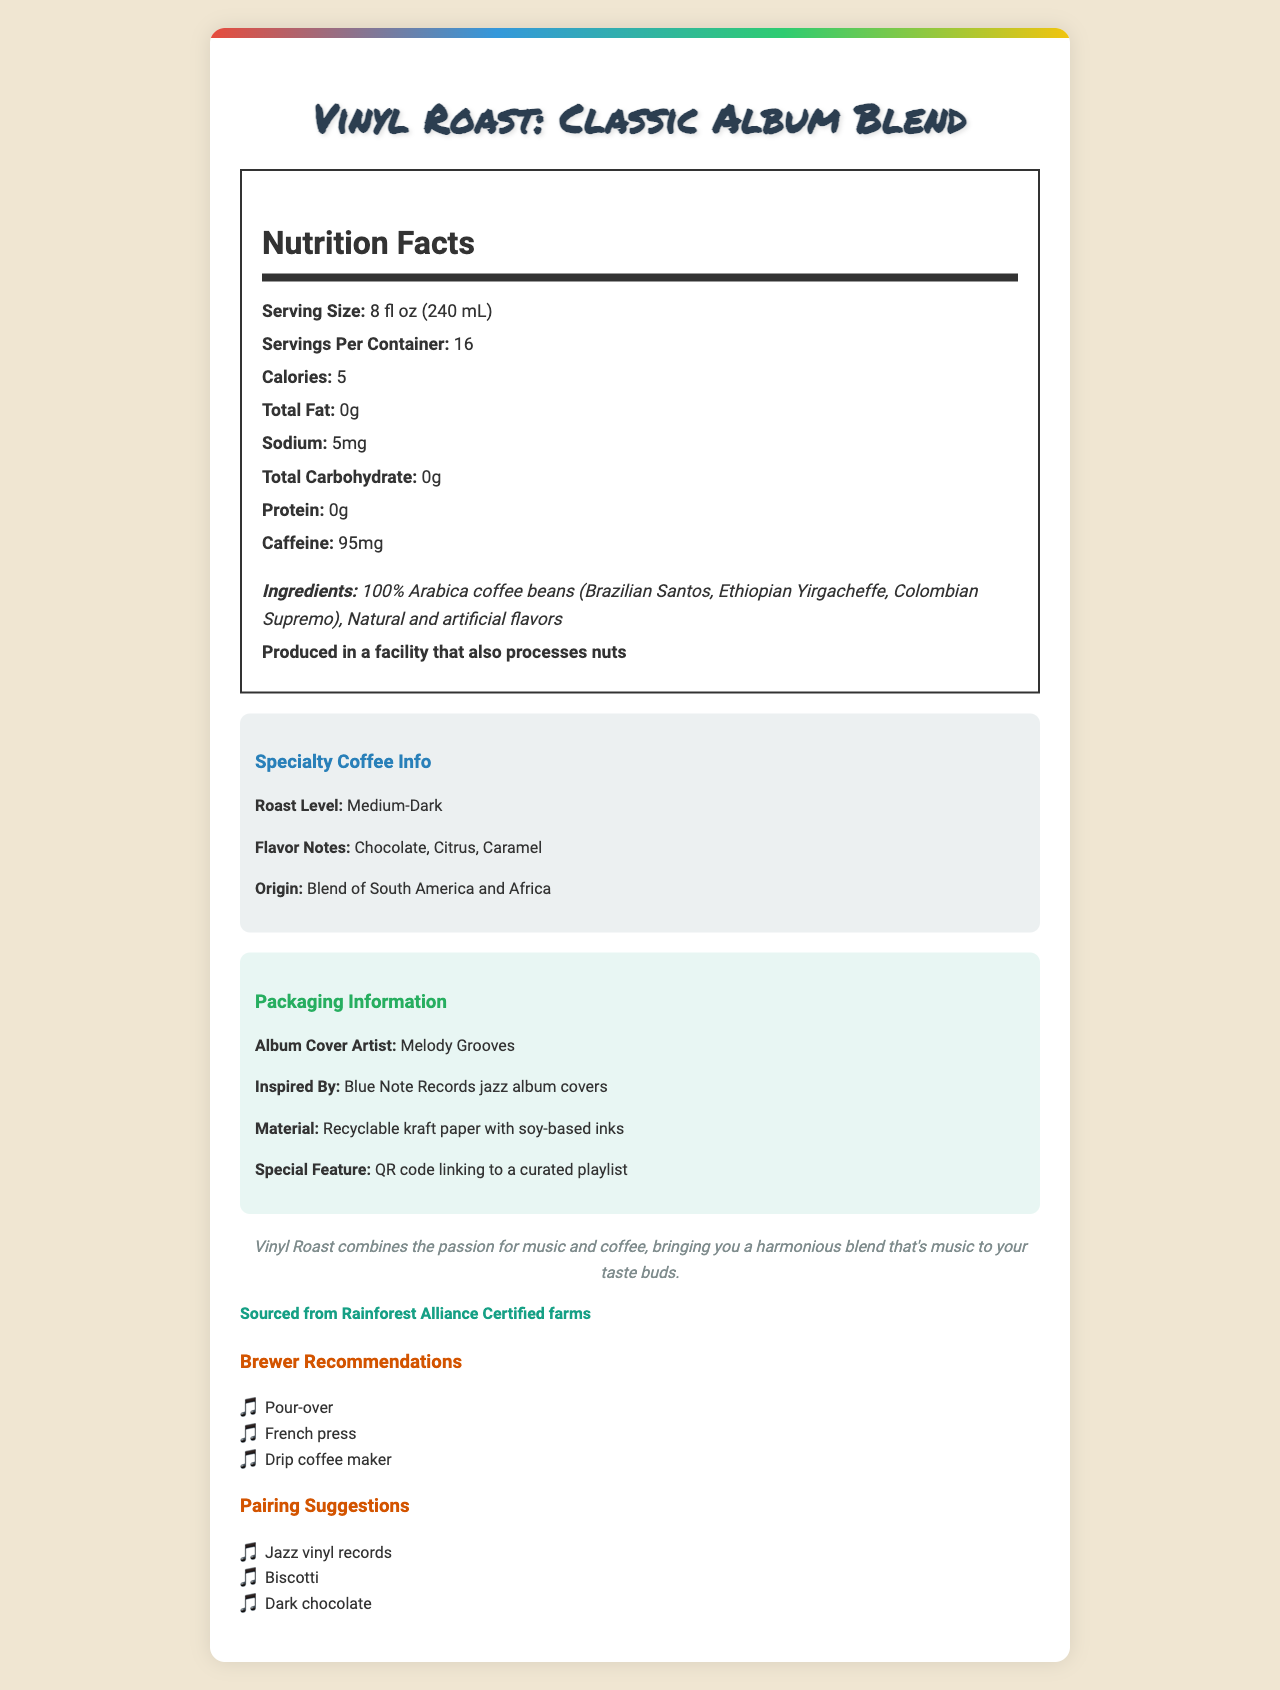what is the serving size? The serving size is listed as "8 fl oz (240 mL)" on the nutrition facts label.
Answer: 8 fl oz (240 mL) How many calories are in one serving? The document states that there are 5 calories per serving.
Answer: 5 What is the caffeine content per serving? According to the nutrition facts, there are 95mg of caffeine per serving.
Answer: 95mg What ingredients are used in Vinyl Roast: Classic Album Blend? The ingredients section lists these components.
Answer: 100% Arabica coffee beans (Brazilian Santos, Ethiopian Yirgacheffe, Colombian Supremo), Natural and artificial flavors Who designed the album cover art? The album cover artist stated in the packaging information is Melody Grooves.
Answer: Melody Grooves What is the roast level of the coffee? The specialty coffee info section lists the roast level as Medium-Dark.
Answer: Medium-Dark What type of packaging material is used? A. Plastic B. Aluminum C. Recyclable kraft paper D. Glass The packaging information specifies that the material type is recyclable kraft paper.
Answer: C. Recyclable kraft paper What inspired the album cover art? A. Classic Rock Albums B. Pop Culture C. Blue Note Records jazz album covers D. 90s Grunge Art The document states that the album cover art is inspired by Blue Note Records jazz album covers.
Answer: C. Blue Note Records jazz album covers Is the coffee sourced sustainably? Yes or No The sustainability info clearly states that the coffee is sourced from Rainforest Alliance Certified farms.
Answer: Yes Summarize the main idea of the document. The main idea of the document is to present comprehensive information about the Vinyl Roast: Classic Album Blend, emphasizing its unique attributes such as the nutritional content, specialty coffee features, and the artistic packaging inspired by music.
Answer: The document provides a detailed overview of Vinyl Roast: Classic Album Blend, highlighting its nutritional facts, ingredients, specialty coffee attributes, packaging details, brand story, sustainability, and recommendations for brewing and pairing. Does the document provide information about the exact caffeine source in the blend? While the document provides the caffeine content per serving, it does not specify the exact source of the caffeine beyond the general ingredient listing of 100% Arabica coffee beans.
Answer: Cannot be determined 